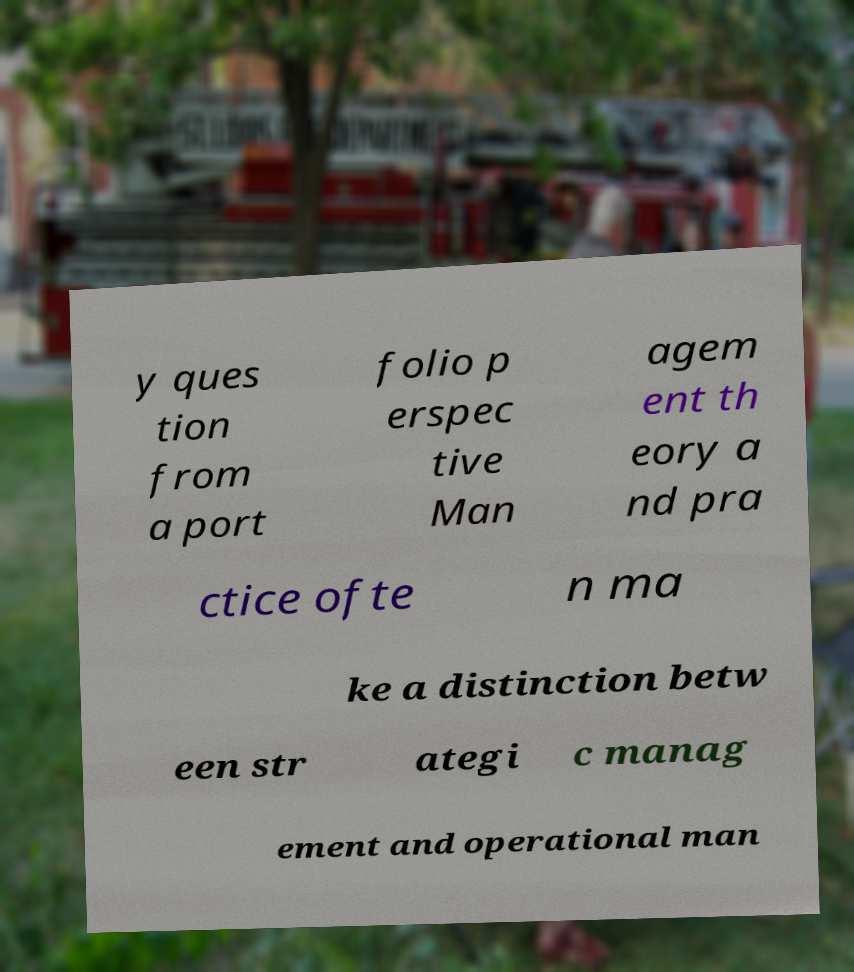Could you assist in decoding the text presented in this image and type it out clearly? y ques tion from a port folio p erspec tive Man agem ent th eory a nd pra ctice ofte n ma ke a distinction betw een str ategi c manag ement and operational man 